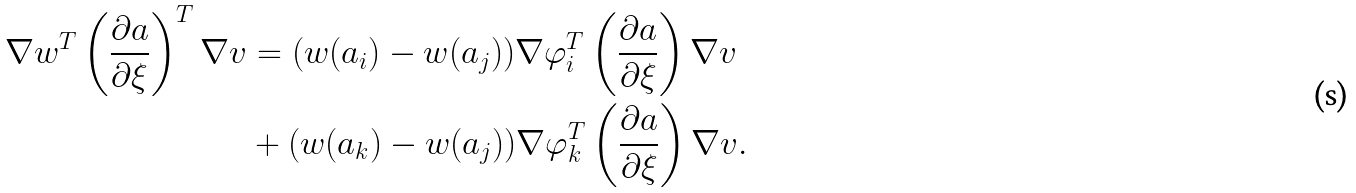<formula> <loc_0><loc_0><loc_500><loc_500>\nabla w ^ { T } \left ( \frac { \partial a } { \partial \xi } \right ) ^ { T } \nabla v & = ( w ( a _ { i } ) - w ( a _ { j } ) ) \nabla \varphi _ { i } ^ { T } \left ( \frac { \partial a } { \partial \xi } \right ) \nabla v \\ & + ( w ( a _ { k } ) - w ( a _ { j } ) ) \nabla \varphi _ { k } ^ { T } \left ( \frac { \partial a } { \partial \xi } \right ) \nabla v .</formula> 